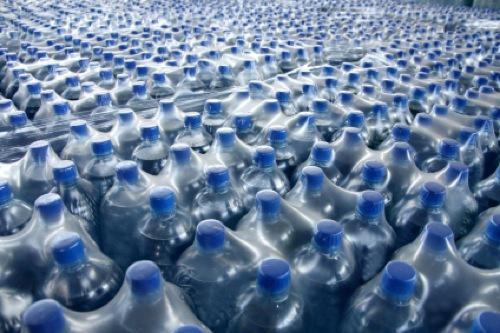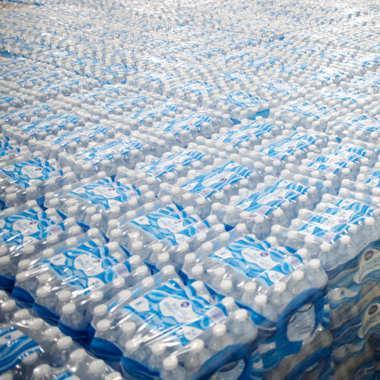The first image is the image on the left, the second image is the image on the right. Assess this claim about the two images: "At least one image shows stacked plastic-wrapped bundles of bottles.". Correct or not? Answer yes or no. Yes. The first image is the image on the left, the second image is the image on the right. For the images displayed, is the sentence "the white capped bottles in the image on the right are sealed in packages of at least 16" factually correct? Answer yes or no. Yes. 